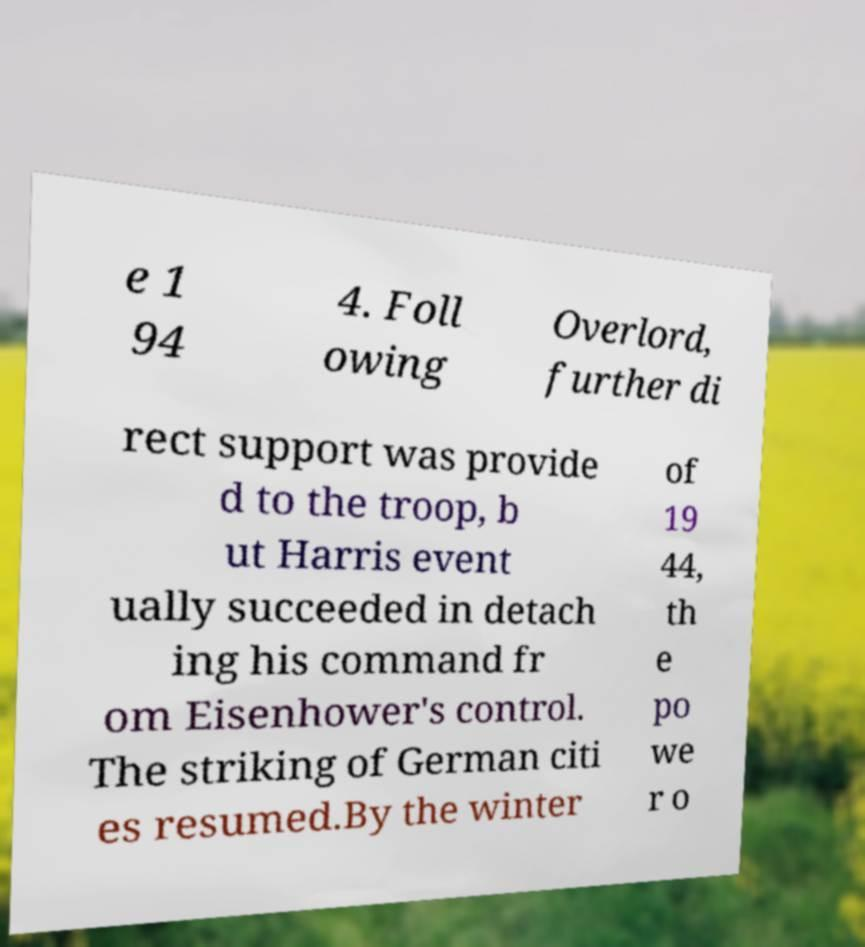There's text embedded in this image that I need extracted. Can you transcribe it verbatim? e 1 94 4. Foll owing Overlord, further di rect support was provide d to the troop, b ut Harris event ually succeeded in detach ing his command fr om Eisenhower's control. The striking of German citi es resumed.By the winter of 19 44, th e po we r o 